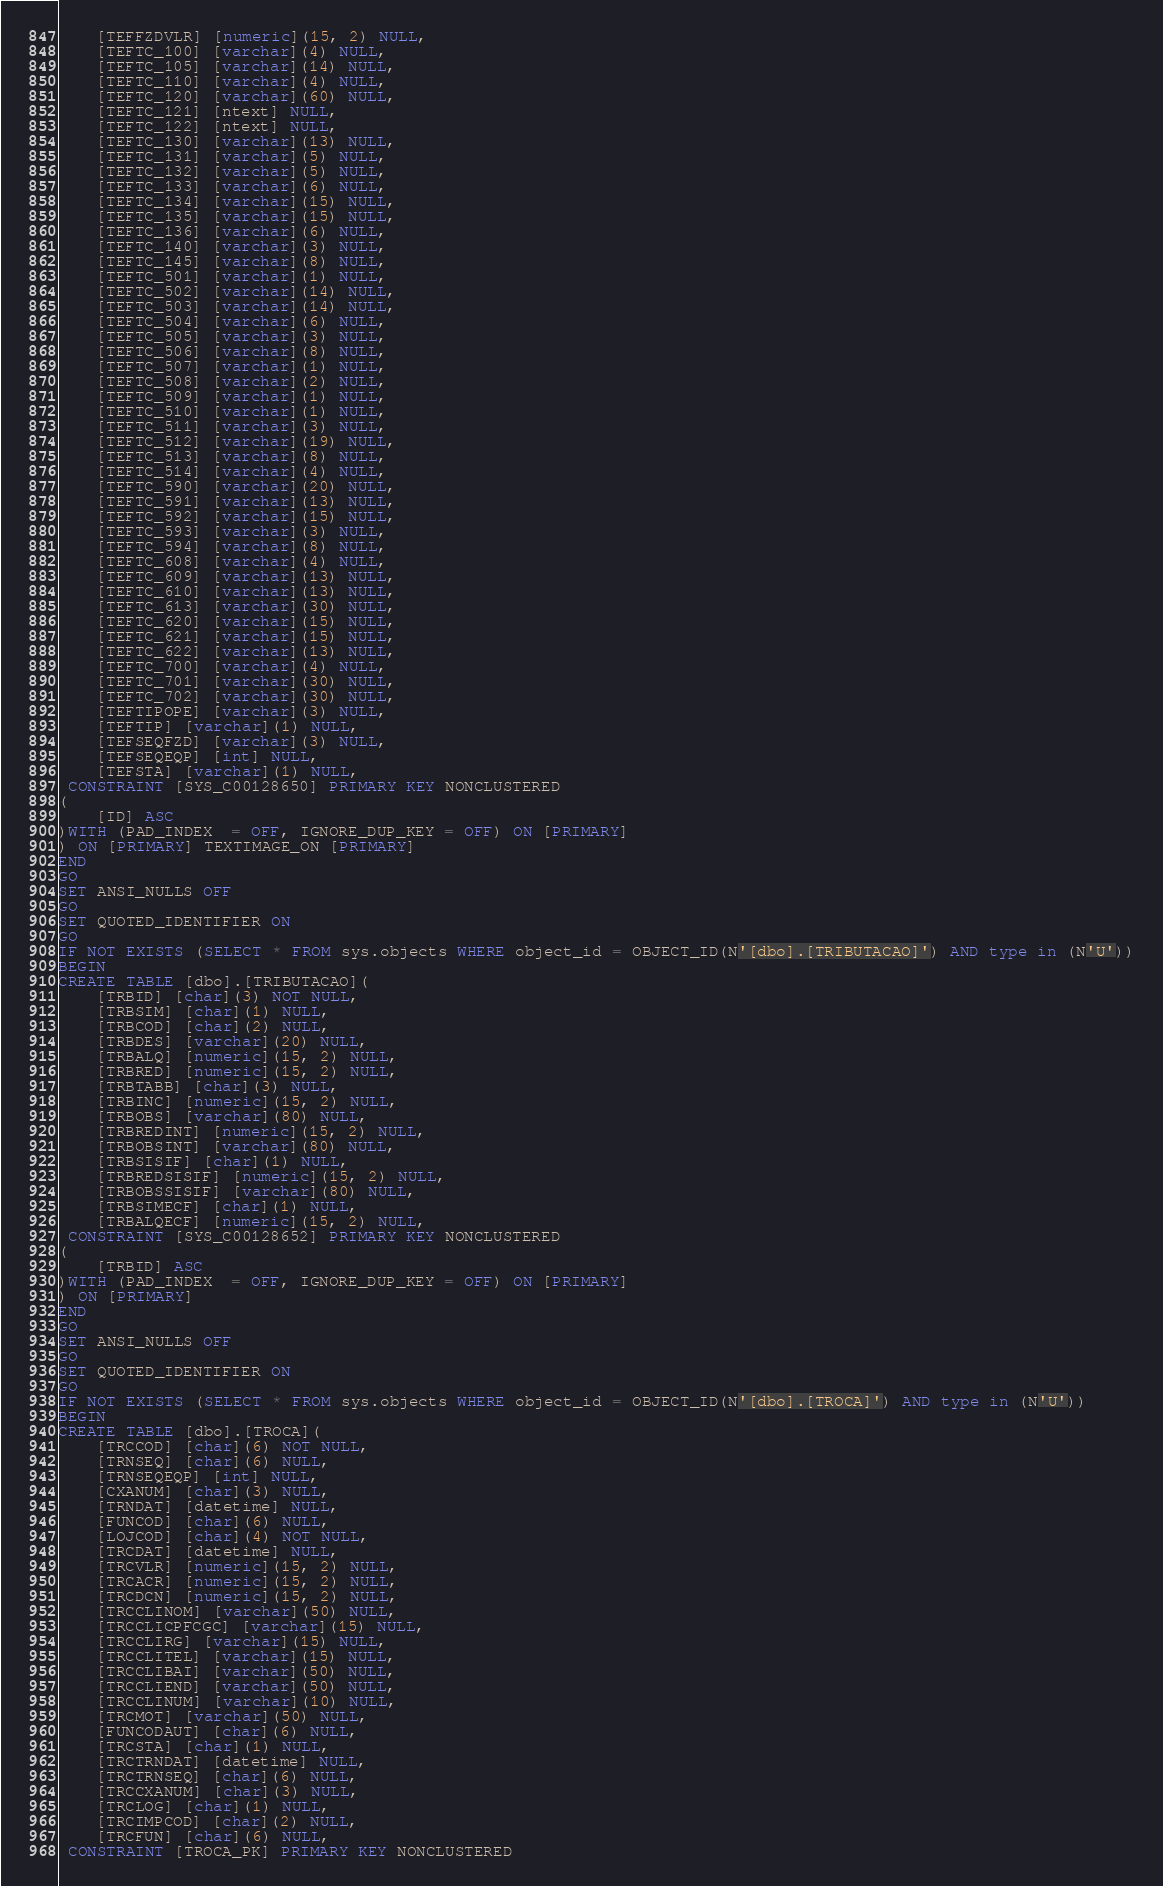<code> <loc_0><loc_0><loc_500><loc_500><_SQL_>	[TEFFZDVLR] [numeric](15, 2) NULL,
	[TEFTC_100] [varchar](4) NULL,
	[TEFTC_105] [varchar](14) NULL,
	[TEFTC_110] [varchar](4) NULL,
	[TEFTC_120] [varchar](60) NULL,
	[TEFTC_121] [ntext] NULL,
	[TEFTC_122] [ntext] NULL,
	[TEFTC_130] [varchar](13) NULL,
	[TEFTC_131] [varchar](5) NULL,
	[TEFTC_132] [varchar](5) NULL,
	[TEFTC_133] [varchar](6) NULL,
	[TEFTC_134] [varchar](15) NULL,
	[TEFTC_135] [varchar](15) NULL,
	[TEFTC_136] [varchar](6) NULL,
	[TEFTC_140] [varchar](3) NULL,
	[TEFTC_145] [varchar](8) NULL,
	[TEFTC_501] [varchar](1) NULL,
	[TEFTC_502] [varchar](14) NULL,
	[TEFTC_503] [varchar](14) NULL,
	[TEFTC_504] [varchar](6) NULL,
	[TEFTC_505] [varchar](3) NULL,
	[TEFTC_506] [varchar](8) NULL,
	[TEFTC_507] [varchar](1) NULL,
	[TEFTC_508] [varchar](2) NULL,
	[TEFTC_509] [varchar](1) NULL,
	[TEFTC_510] [varchar](1) NULL,
	[TEFTC_511] [varchar](3) NULL,
	[TEFTC_512] [varchar](19) NULL,
	[TEFTC_513] [varchar](8) NULL,
	[TEFTC_514] [varchar](4) NULL,
	[TEFTC_590] [varchar](20) NULL,
	[TEFTC_591] [varchar](13) NULL,
	[TEFTC_592] [varchar](15) NULL,
	[TEFTC_593] [varchar](3) NULL,
	[TEFTC_594] [varchar](8) NULL,
	[TEFTC_608] [varchar](4) NULL,
	[TEFTC_609] [varchar](13) NULL,
	[TEFTC_610] [varchar](13) NULL,
	[TEFTC_613] [varchar](30) NULL,
	[TEFTC_620] [varchar](15) NULL,
	[TEFTC_621] [varchar](15) NULL,
	[TEFTC_622] [varchar](13) NULL,
	[TEFTC_700] [varchar](4) NULL,
	[TEFTC_701] [varchar](30) NULL,
	[TEFTC_702] [varchar](30) NULL,
	[TEFTIPOPE] [varchar](3) NULL,
	[TEFTIP] [varchar](1) NULL,
	[TEFSEQFZD] [varchar](3) NULL,
	[TEFSEQEQP] [int] NULL,
	[TEFSTA] [varchar](1) NULL,
 CONSTRAINT [SYS_C00128650] PRIMARY KEY NONCLUSTERED 
(
	[ID] ASC
)WITH (PAD_INDEX  = OFF, IGNORE_DUP_KEY = OFF) ON [PRIMARY]
) ON [PRIMARY] TEXTIMAGE_ON [PRIMARY]
END
GO
SET ANSI_NULLS OFF
GO
SET QUOTED_IDENTIFIER ON
GO
IF NOT EXISTS (SELECT * FROM sys.objects WHERE object_id = OBJECT_ID(N'[dbo].[TRIBUTACAO]') AND type in (N'U'))
BEGIN
CREATE TABLE [dbo].[TRIBUTACAO](
	[TRBID] [char](3) NOT NULL,
	[TRBSIM] [char](1) NULL,
	[TRBCOD] [char](2) NULL,
	[TRBDES] [varchar](20) NULL,
	[TRBALQ] [numeric](15, 2) NULL,
	[TRBRED] [numeric](15, 2) NULL,
	[TRBTABB] [char](3) NULL,
	[TRBINC] [numeric](15, 2) NULL,
	[TRBOBS] [varchar](80) NULL,
	[TRBREDINT] [numeric](15, 2) NULL,
	[TRBOBSINT] [varchar](80) NULL,
	[TRBSISIF] [char](1) NULL,
	[TRBREDSISIF] [numeric](15, 2) NULL,
	[TRBOBSSISIF] [varchar](80) NULL,
	[TRBSIMECF] [char](1) NULL,
	[TRBALQECF] [numeric](15, 2) NULL,
 CONSTRAINT [SYS_C00128652] PRIMARY KEY NONCLUSTERED 
(
	[TRBID] ASC
)WITH (PAD_INDEX  = OFF, IGNORE_DUP_KEY = OFF) ON [PRIMARY]
) ON [PRIMARY]
END
GO
SET ANSI_NULLS OFF
GO
SET QUOTED_IDENTIFIER ON
GO
IF NOT EXISTS (SELECT * FROM sys.objects WHERE object_id = OBJECT_ID(N'[dbo].[TROCA]') AND type in (N'U'))
BEGIN
CREATE TABLE [dbo].[TROCA](
	[TRCCOD] [char](6) NOT NULL,
	[TRNSEQ] [char](6) NULL,
	[TRNSEQEQP] [int] NULL,
	[CXANUM] [char](3) NULL,
	[TRNDAT] [datetime] NULL,
	[FUNCOD] [char](6) NULL,
	[LOJCOD] [char](4) NOT NULL,
	[TRCDAT] [datetime] NULL,
	[TRCVLR] [numeric](15, 2) NULL,
	[TRCACR] [numeric](15, 2) NULL,
	[TRCDCN] [numeric](15, 2) NULL,
	[TRCCLINOM] [varchar](50) NULL,
	[TRCCLICPFCGC] [varchar](15) NULL,
	[TRCCLIRG] [varchar](15) NULL,
	[TRCCLITEL] [varchar](15) NULL,
	[TRCCLIBAI] [varchar](50) NULL,
	[TRCCLIEND] [varchar](50) NULL,
	[TRCCLINUM] [varchar](10) NULL,
	[TRCMOT] [varchar](50) NULL,
	[FUNCODAUT] [char](6) NULL,
	[TRCSTA] [char](1) NULL,
	[TRCTRNDAT] [datetime] NULL,
	[TRCTRNSEQ] [char](6) NULL,
	[TRCCXANUM] [char](3) NULL,
	[TRCLOG] [char](1) NULL,
	[TRCIMPCOD] [char](2) NULL,
	[TRCFUN] [char](6) NULL,
 CONSTRAINT [TROCA_PK] PRIMARY KEY NONCLUSTERED </code> 